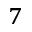Convert formula to latex. <formula><loc_0><loc_0><loc_500><loc_500>^ { 7 }</formula> 